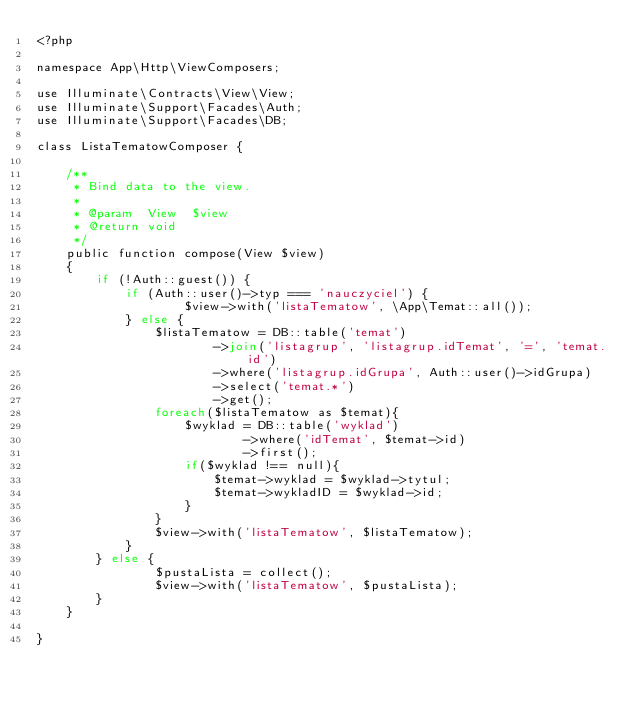<code> <loc_0><loc_0><loc_500><loc_500><_PHP_><?php

namespace App\Http\ViewComposers;

use Illuminate\Contracts\View\View;
use Illuminate\Support\Facades\Auth;
use Illuminate\Support\Facades\DB;

class ListaTematowComposer {

    /**
     * Bind data to the view.
     *
     * @param  View  $view
     * @return void
     */
    public function compose(View $view)
    {
        if (!Auth::guest()) {
            if (Auth::user()->typ === 'nauczyciel') {
                    $view->with('listaTematow', \App\Temat::all());
            } else {
                $listaTematow = DB::table('temat')
                        ->join('listagrup', 'listagrup.idTemat', '=', 'temat.id')
                        ->where('listagrup.idGrupa', Auth::user()->idGrupa)
                        ->select('temat.*')
                        ->get();
                foreach($listaTematow as $temat){
                    $wyklad = DB::table('wyklad')
                            ->where('idTemat', $temat->id)
                            ->first();
                    if($wyklad !== null){
                        $temat->wyklad = $wyklad->tytul;
                        $temat->wykladID = $wyklad->id;
                    }
                }
                $view->with('listaTematow', $listaTematow);
            }
        } else {
                $pustaLista = collect();
                $view->with('listaTematow', $pustaLista);
        }
    }

}</code> 